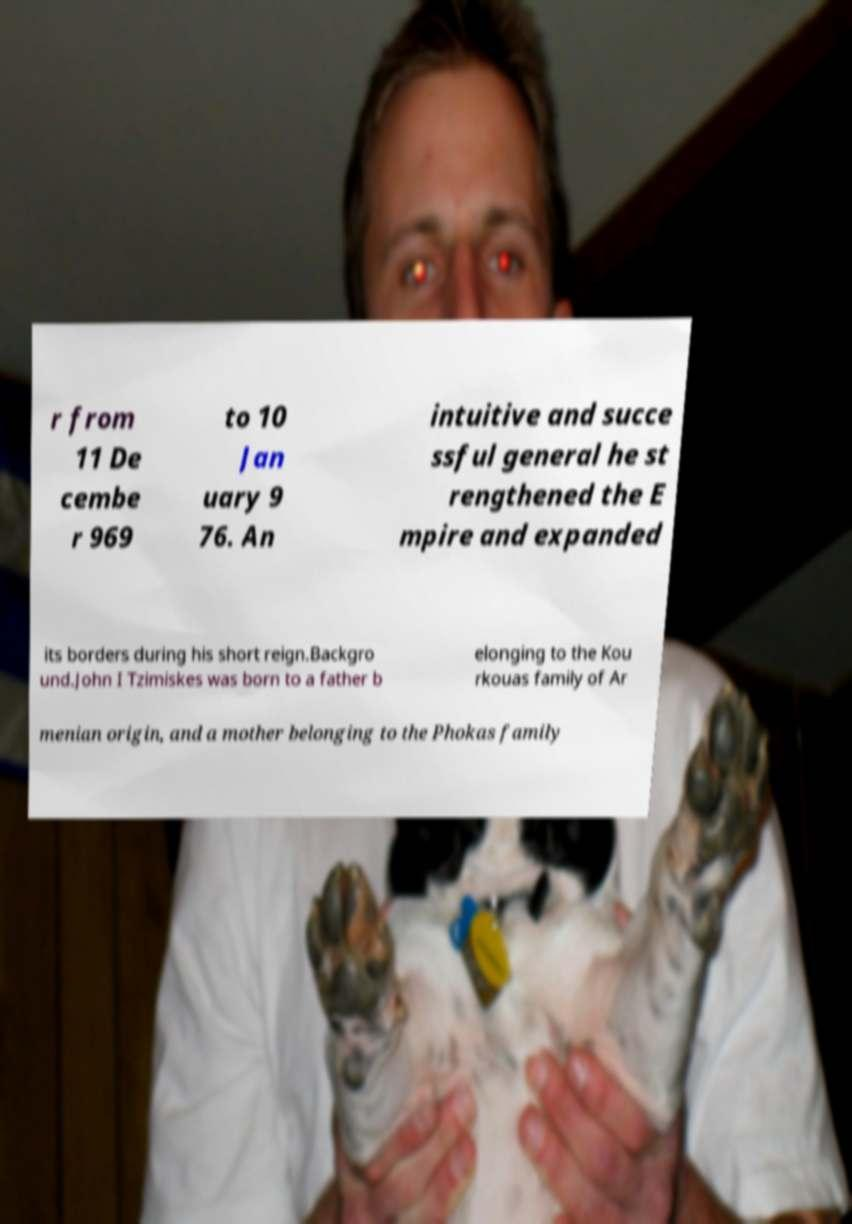Please identify and transcribe the text found in this image. r from 11 De cembe r 969 to 10 Jan uary 9 76. An intuitive and succe ssful general he st rengthened the E mpire and expanded its borders during his short reign.Backgro und.John I Tzimiskes was born to a father b elonging to the Kou rkouas family of Ar menian origin, and a mother belonging to the Phokas family 